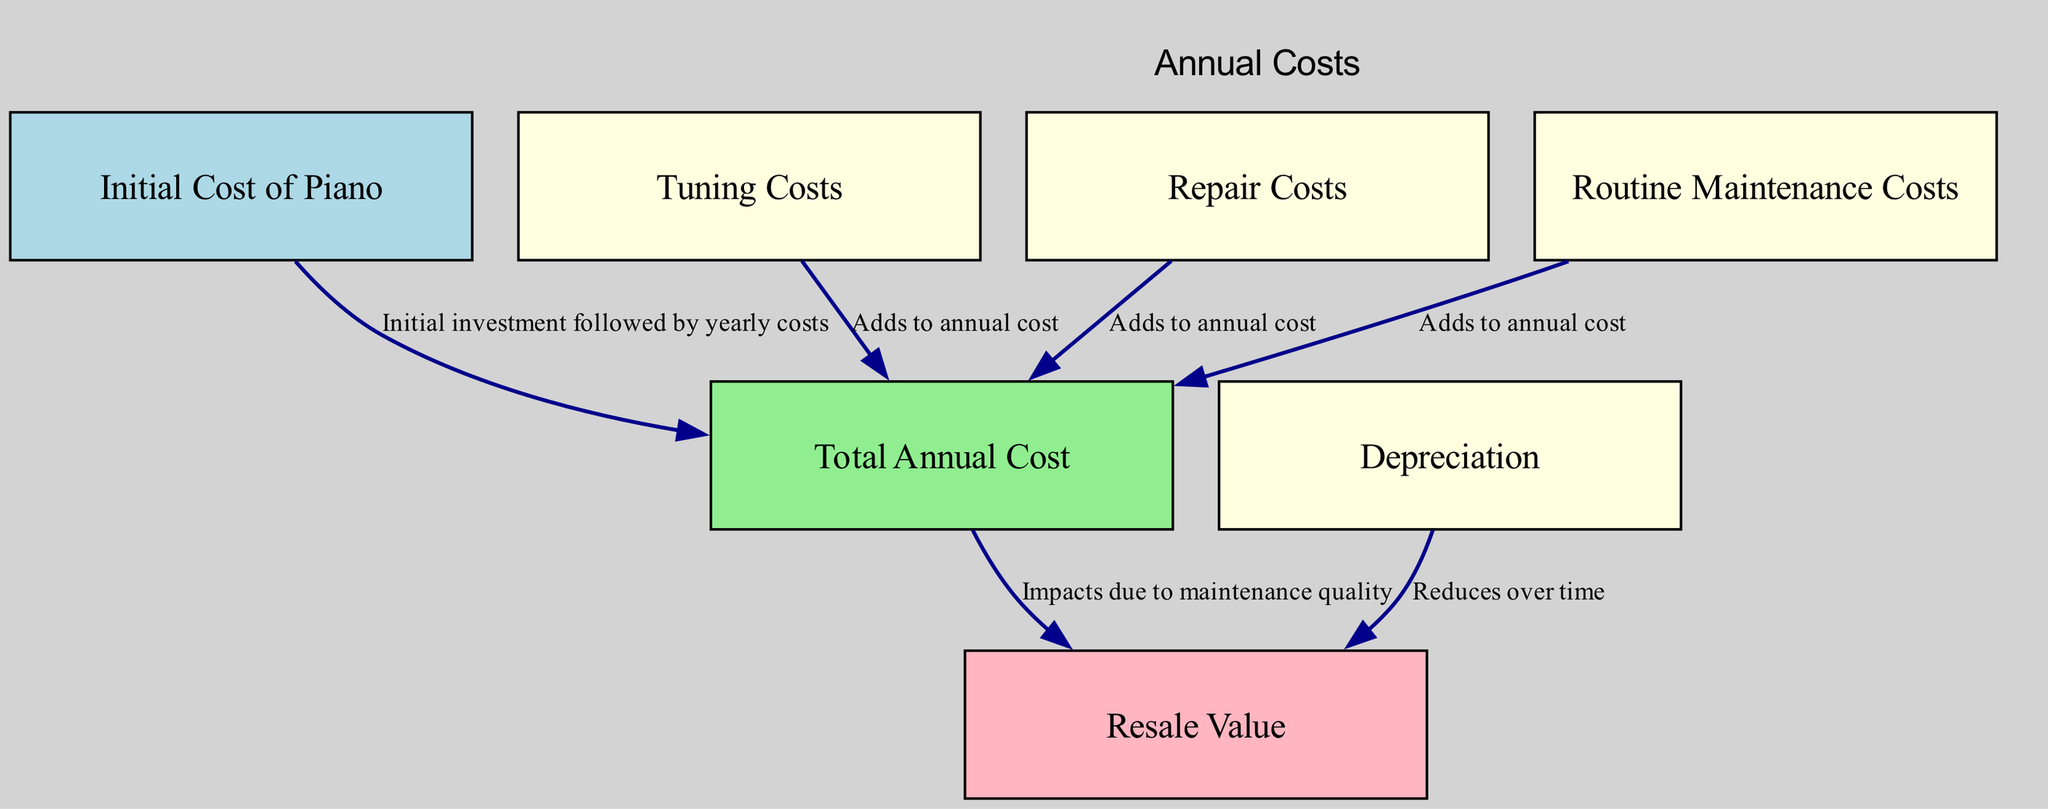What is the initial investment represented in the diagram? The diagram identifies "Initial Cost of Piano" as a node, which represents the initial investment or the purchase price of a new or used piano.
Answer: Initial Cost of Piano How frequently are tuning costs incurred? The node "Tuning Costs" indicates that this expense is typically incurred every 6 months, which is half a year.
Answer: Every 6 months Which node directly impacts the resale value? The "Total Annual Cost" node impacts the "Resale Value" according to the edge connecting them, indicating that maintenance quality affects what the piano can be sold for later.
Answer: Total Annual Cost What describes the relationship between total annual cost and maintenance quality? The edge from "Total Annual Cost" to "Resale Value" indicates that higher maintenance quality, reflected in the total annual costs, influences the piano's resale value.
Answer: Impacts due to maintenance quality How does depreciation affect the resale value over time? The "Depreciation" node shows that it reduces the value of the piano, which is linked to the "Resale Value" node through the edge, indicating a negative impact as time passes.
Answer: Reduces over time What is the total number of nodes in the diagram? Counting all the nodes listed, there are a total of 7 nodes representing different aspects of piano costs and value in the diagram.
Answer: 7 nodes What type of costs are included in the total annual cost? The edges show that "Tuning Costs," "Repair Costs," and "Routine Maintenance Costs" all add to the "Total Annual Cost," indicating these are the included expenses.
Answer: Tuning, Repair, Maintenance costs What does the diagram suggest about the relationship between initial cost and total annual cost? The edge from "Initial Cost of Piano" to "Total Annual Cost" suggests that the initial investment leads to ongoing yearly expenses associated with maintaining the piano.
Answer: Initial investment followed by yearly costs 